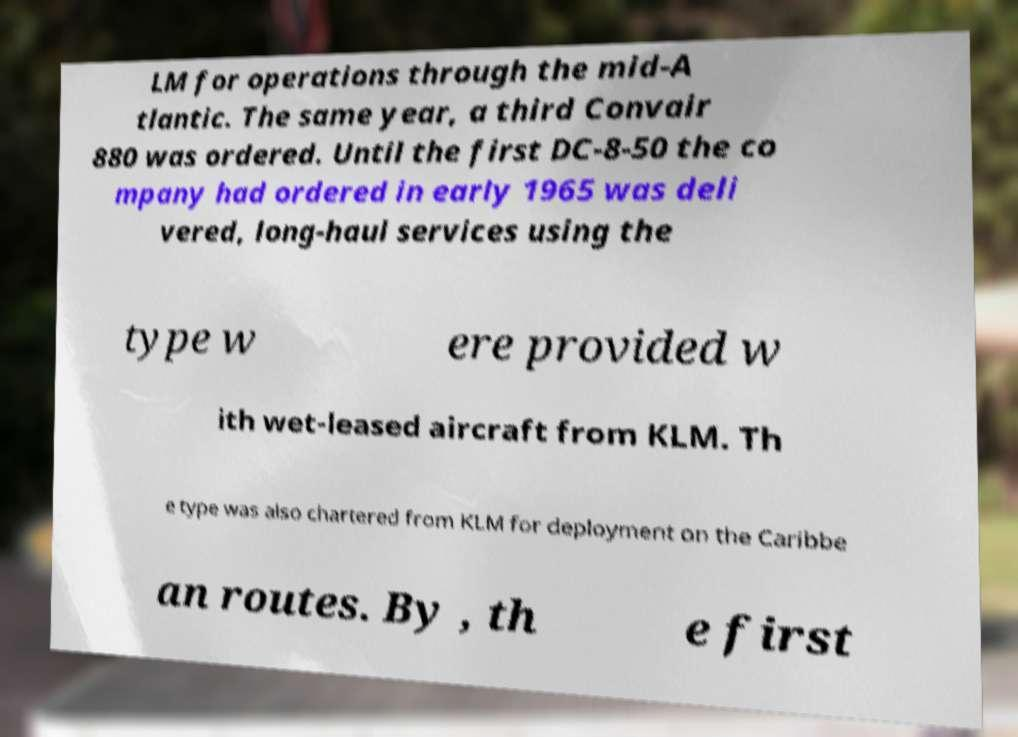Could you assist in decoding the text presented in this image and type it out clearly? LM for operations through the mid-A tlantic. The same year, a third Convair 880 was ordered. Until the first DC-8-50 the co mpany had ordered in early 1965 was deli vered, long-haul services using the type w ere provided w ith wet-leased aircraft from KLM. Th e type was also chartered from KLM for deployment on the Caribbe an routes. By , th e first 